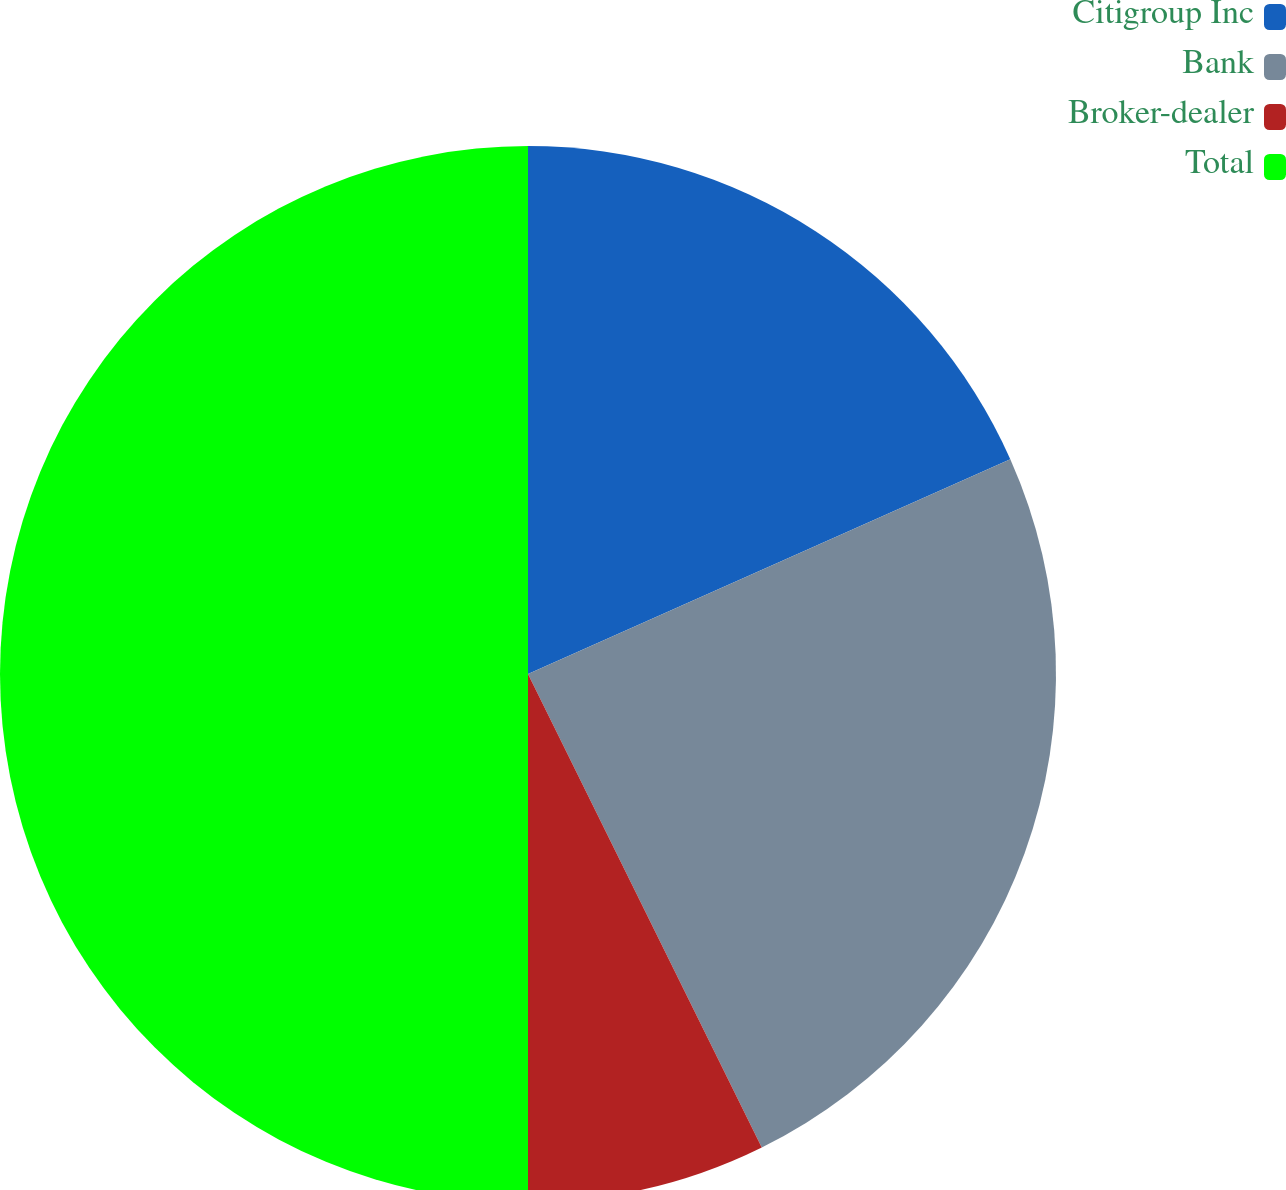Convert chart. <chart><loc_0><loc_0><loc_500><loc_500><pie_chart><fcel>Citigroup Inc<fcel>Bank<fcel>Broker-dealer<fcel>Total<nl><fcel>18.33%<fcel>24.37%<fcel>7.3%<fcel>50.0%<nl></chart> 